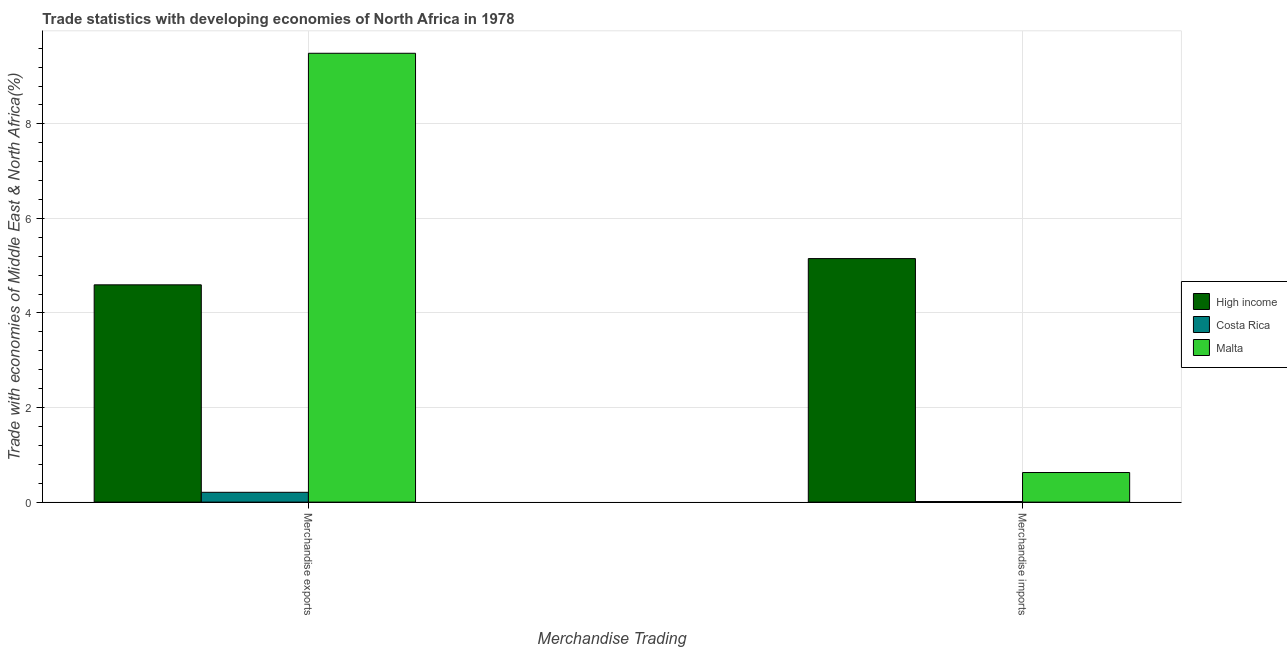How many groups of bars are there?
Give a very brief answer. 2. What is the label of the 1st group of bars from the left?
Provide a short and direct response. Merchandise exports. What is the merchandise imports in Costa Rica?
Ensure brevity in your answer.  0.01. Across all countries, what is the maximum merchandise exports?
Make the answer very short. 9.49. Across all countries, what is the minimum merchandise exports?
Offer a terse response. 0.21. In which country was the merchandise imports maximum?
Ensure brevity in your answer.  High income. In which country was the merchandise imports minimum?
Offer a terse response. Costa Rica. What is the total merchandise exports in the graph?
Offer a terse response. 14.3. What is the difference between the merchandise exports in Malta and that in Costa Rica?
Keep it short and to the point. 9.29. What is the difference between the merchandise exports in Malta and the merchandise imports in High income?
Your answer should be very brief. 4.34. What is the average merchandise exports per country?
Provide a succinct answer. 4.77. What is the difference between the merchandise imports and merchandise exports in High income?
Ensure brevity in your answer.  0.56. What is the ratio of the merchandise exports in High income to that in Malta?
Make the answer very short. 0.48. Is the merchandise imports in High income less than that in Costa Rica?
Offer a very short reply. No. In how many countries, is the merchandise imports greater than the average merchandise imports taken over all countries?
Keep it short and to the point. 1. What does the 1st bar from the right in Merchandise exports represents?
Offer a terse response. Malta. How many bars are there?
Ensure brevity in your answer.  6. Are all the bars in the graph horizontal?
Make the answer very short. No. What is the title of the graph?
Make the answer very short. Trade statistics with developing economies of North Africa in 1978. What is the label or title of the X-axis?
Provide a short and direct response. Merchandise Trading. What is the label or title of the Y-axis?
Provide a succinct answer. Trade with economies of Middle East & North Africa(%). What is the Trade with economies of Middle East & North Africa(%) of High income in Merchandise exports?
Keep it short and to the point. 4.6. What is the Trade with economies of Middle East & North Africa(%) of Costa Rica in Merchandise exports?
Offer a very short reply. 0.21. What is the Trade with economies of Middle East & North Africa(%) in Malta in Merchandise exports?
Provide a short and direct response. 9.49. What is the Trade with economies of Middle East & North Africa(%) in High income in Merchandise imports?
Give a very brief answer. 5.15. What is the Trade with economies of Middle East & North Africa(%) in Costa Rica in Merchandise imports?
Your response must be concise. 0.01. What is the Trade with economies of Middle East & North Africa(%) of Malta in Merchandise imports?
Give a very brief answer. 0.63. Across all Merchandise Trading, what is the maximum Trade with economies of Middle East & North Africa(%) of High income?
Your answer should be very brief. 5.15. Across all Merchandise Trading, what is the maximum Trade with economies of Middle East & North Africa(%) of Costa Rica?
Provide a short and direct response. 0.21. Across all Merchandise Trading, what is the maximum Trade with economies of Middle East & North Africa(%) of Malta?
Give a very brief answer. 9.49. Across all Merchandise Trading, what is the minimum Trade with economies of Middle East & North Africa(%) in High income?
Provide a short and direct response. 4.6. Across all Merchandise Trading, what is the minimum Trade with economies of Middle East & North Africa(%) in Costa Rica?
Provide a succinct answer. 0.01. Across all Merchandise Trading, what is the minimum Trade with economies of Middle East & North Africa(%) in Malta?
Provide a succinct answer. 0.63. What is the total Trade with economies of Middle East & North Africa(%) in High income in the graph?
Your response must be concise. 9.75. What is the total Trade with economies of Middle East & North Africa(%) of Costa Rica in the graph?
Keep it short and to the point. 0.22. What is the total Trade with economies of Middle East & North Africa(%) in Malta in the graph?
Offer a terse response. 10.12. What is the difference between the Trade with economies of Middle East & North Africa(%) of High income in Merchandise exports and that in Merchandise imports?
Keep it short and to the point. -0.56. What is the difference between the Trade with economies of Middle East & North Africa(%) in Costa Rica in Merchandise exports and that in Merchandise imports?
Provide a succinct answer. 0.2. What is the difference between the Trade with economies of Middle East & North Africa(%) in Malta in Merchandise exports and that in Merchandise imports?
Keep it short and to the point. 8.87. What is the difference between the Trade with economies of Middle East & North Africa(%) in High income in Merchandise exports and the Trade with economies of Middle East & North Africa(%) in Costa Rica in Merchandise imports?
Your answer should be compact. 4.58. What is the difference between the Trade with economies of Middle East & North Africa(%) of High income in Merchandise exports and the Trade with economies of Middle East & North Africa(%) of Malta in Merchandise imports?
Provide a short and direct response. 3.97. What is the difference between the Trade with economies of Middle East & North Africa(%) in Costa Rica in Merchandise exports and the Trade with economies of Middle East & North Africa(%) in Malta in Merchandise imports?
Provide a succinct answer. -0.42. What is the average Trade with economies of Middle East & North Africa(%) in High income per Merchandise Trading?
Provide a succinct answer. 4.87. What is the average Trade with economies of Middle East & North Africa(%) in Costa Rica per Merchandise Trading?
Keep it short and to the point. 0.11. What is the average Trade with economies of Middle East & North Africa(%) of Malta per Merchandise Trading?
Your answer should be compact. 5.06. What is the difference between the Trade with economies of Middle East & North Africa(%) of High income and Trade with economies of Middle East & North Africa(%) of Costa Rica in Merchandise exports?
Offer a very short reply. 4.39. What is the difference between the Trade with economies of Middle East & North Africa(%) of High income and Trade with economies of Middle East & North Africa(%) of Malta in Merchandise exports?
Make the answer very short. -4.9. What is the difference between the Trade with economies of Middle East & North Africa(%) of Costa Rica and Trade with economies of Middle East & North Africa(%) of Malta in Merchandise exports?
Your answer should be very brief. -9.29. What is the difference between the Trade with economies of Middle East & North Africa(%) of High income and Trade with economies of Middle East & North Africa(%) of Costa Rica in Merchandise imports?
Offer a terse response. 5.14. What is the difference between the Trade with economies of Middle East & North Africa(%) of High income and Trade with economies of Middle East & North Africa(%) of Malta in Merchandise imports?
Your answer should be very brief. 4.52. What is the difference between the Trade with economies of Middle East & North Africa(%) in Costa Rica and Trade with economies of Middle East & North Africa(%) in Malta in Merchandise imports?
Offer a terse response. -0.61. What is the ratio of the Trade with economies of Middle East & North Africa(%) in High income in Merchandise exports to that in Merchandise imports?
Your response must be concise. 0.89. What is the ratio of the Trade with economies of Middle East & North Africa(%) of Costa Rica in Merchandise exports to that in Merchandise imports?
Ensure brevity in your answer.  16.79. What is the ratio of the Trade with economies of Middle East & North Africa(%) of Malta in Merchandise exports to that in Merchandise imports?
Make the answer very short. 15.17. What is the difference between the highest and the second highest Trade with economies of Middle East & North Africa(%) of High income?
Offer a terse response. 0.56. What is the difference between the highest and the second highest Trade with economies of Middle East & North Africa(%) in Costa Rica?
Give a very brief answer. 0.2. What is the difference between the highest and the second highest Trade with economies of Middle East & North Africa(%) in Malta?
Ensure brevity in your answer.  8.87. What is the difference between the highest and the lowest Trade with economies of Middle East & North Africa(%) in High income?
Give a very brief answer. 0.56. What is the difference between the highest and the lowest Trade with economies of Middle East & North Africa(%) of Costa Rica?
Provide a succinct answer. 0.2. What is the difference between the highest and the lowest Trade with economies of Middle East & North Africa(%) in Malta?
Keep it short and to the point. 8.87. 